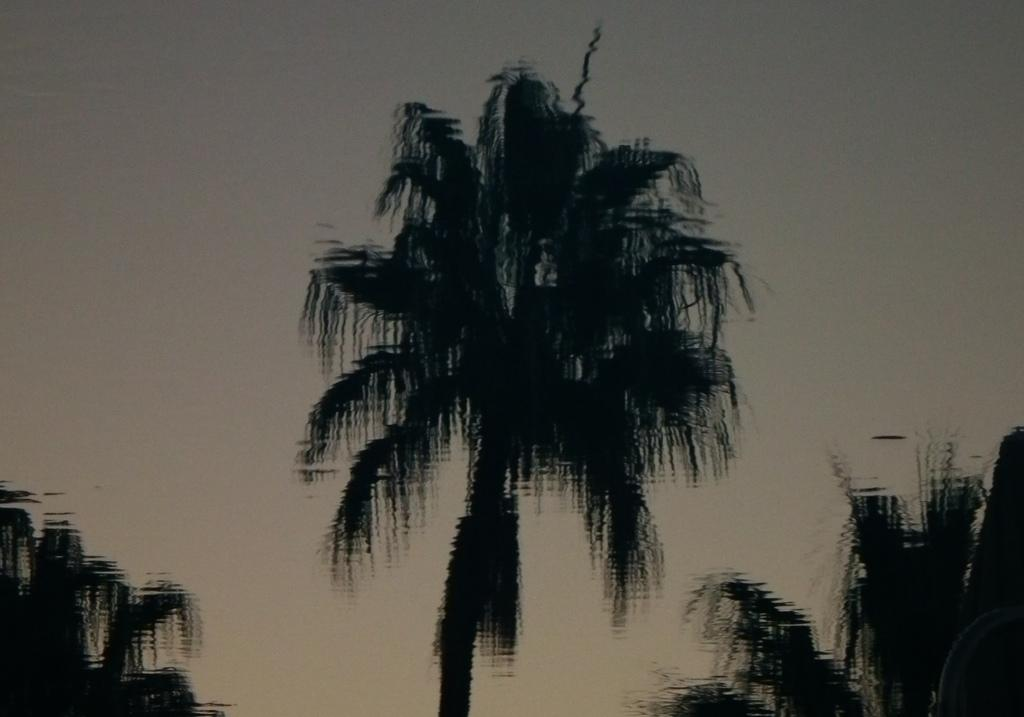What type of vegetation is present in the image? The image contains blurry trees. What can be seen in the background of the image? There is sky visible in the background of the image. How many stitches are required to sew the straw in the image? There is no straw or stitching present in the image; it features blurry trees and sky. 